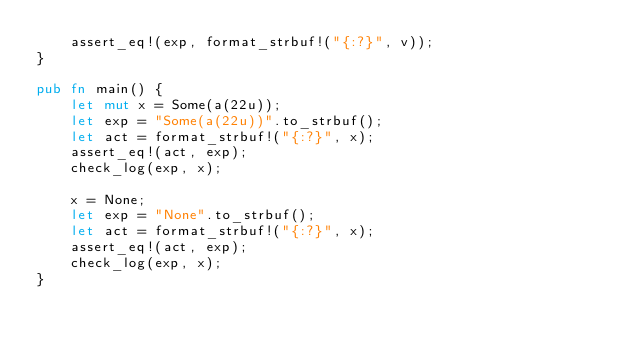Convert code to text. <code><loc_0><loc_0><loc_500><loc_500><_Rust_>    assert_eq!(exp, format_strbuf!("{:?}", v));
}

pub fn main() {
    let mut x = Some(a(22u));
    let exp = "Some(a(22u))".to_strbuf();
    let act = format_strbuf!("{:?}", x);
    assert_eq!(act, exp);
    check_log(exp, x);

    x = None;
    let exp = "None".to_strbuf();
    let act = format_strbuf!("{:?}", x);
    assert_eq!(act, exp);
    check_log(exp, x);
}
</code> 